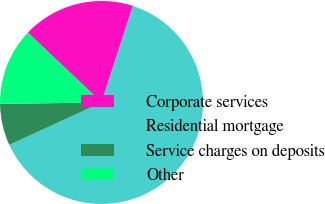<chart> <loc_0><loc_0><loc_500><loc_500><pie_chart><fcel>Corporate services<fcel>Residential mortgage<fcel>Service charges on deposits<fcel>Other<nl><fcel>17.94%<fcel>63.12%<fcel>6.64%<fcel>12.29%<nl></chart> 